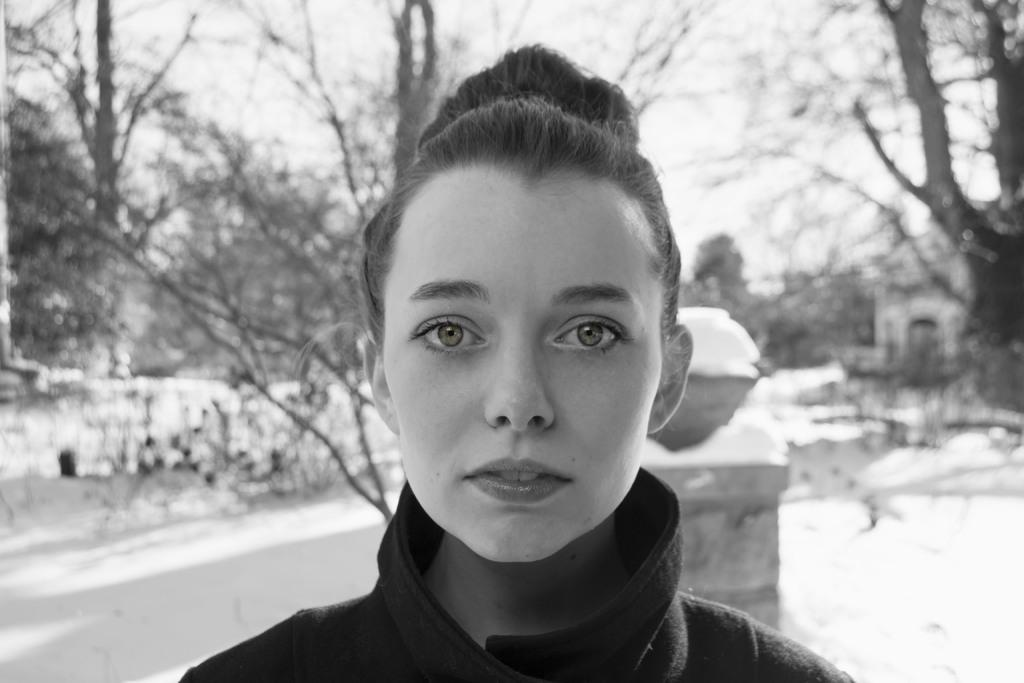Who is the main subject in the image? There is a lady in the center of the image. What can be seen in the background of the image? There are trees and a pillar visible in the background of the image. What is the weather like in the image? There is snow visible in the image, indicating a cold or wintery condition. What type of toe is sticking out from under the lady's dress in the image? There is no toe visible in the image; the lady's dress covers her feet. 